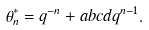Convert formula to latex. <formula><loc_0><loc_0><loc_500><loc_500>\theta ^ { * } _ { n } = q ^ { - n } + a b c d q ^ { n - 1 } .</formula> 